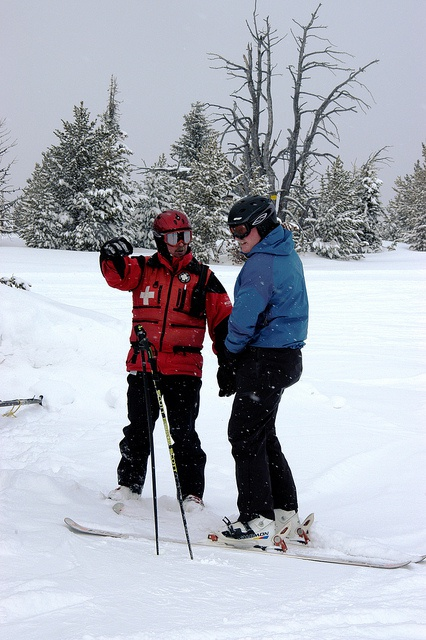Describe the objects in this image and their specific colors. I can see people in lightgray, black, maroon, brown, and white tones, people in lightgray, black, blue, navy, and darkgray tones, skis in lightgray, lavender, darkgray, and gray tones, and skis in lightgray and darkgray tones in this image. 